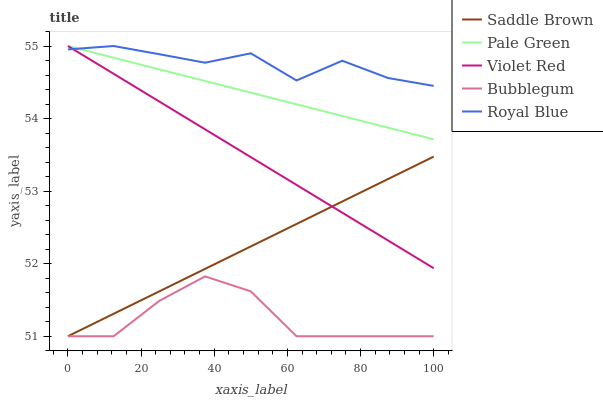Does Bubblegum have the minimum area under the curve?
Answer yes or no. Yes. Does Royal Blue have the maximum area under the curve?
Answer yes or no. Yes. Does Violet Red have the minimum area under the curve?
Answer yes or no. No. Does Violet Red have the maximum area under the curve?
Answer yes or no. No. Is Violet Red the smoothest?
Answer yes or no. Yes. Is Bubblegum the roughest?
Answer yes or no. Yes. Is Pale Green the smoothest?
Answer yes or no. No. Is Pale Green the roughest?
Answer yes or no. No. Does Saddle Brown have the lowest value?
Answer yes or no. Yes. Does Violet Red have the lowest value?
Answer yes or no. No. Does Pale Green have the highest value?
Answer yes or no. Yes. Does Saddle Brown have the highest value?
Answer yes or no. No. Is Bubblegum less than Violet Red?
Answer yes or no. Yes. Is Royal Blue greater than Saddle Brown?
Answer yes or no. Yes. Does Violet Red intersect Saddle Brown?
Answer yes or no. Yes. Is Violet Red less than Saddle Brown?
Answer yes or no. No. Is Violet Red greater than Saddle Brown?
Answer yes or no. No. Does Bubblegum intersect Violet Red?
Answer yes or no. No. 